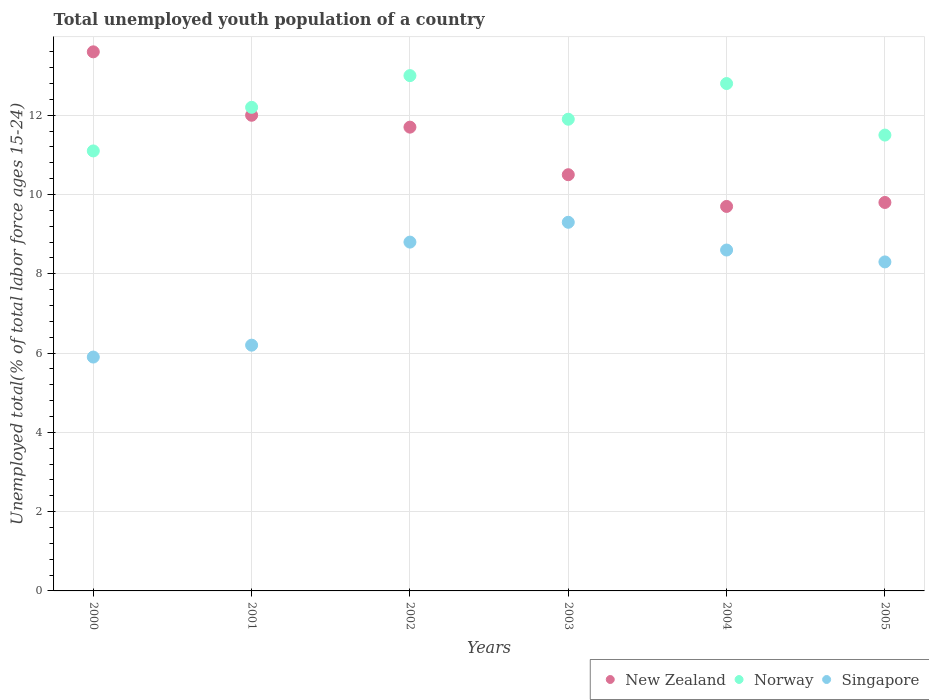What is the percentage of total unemployed youth population of a country in Norway in 2000?
Offer a very short reply. 11.1. Across all years, what is the maximum percentage of total unemployed youth population of a country in New Zealand?
Offer a very short reply. 13.6. Across all years, what is the minimum percentage of total unemployed youth population of a country in New Zealand?
Give a very brief answer. 9.7. In which year was the percentage of total unemployed youth population of a country in New Zealand minimum?
Your answer should be compact. 2004. What is the total percentage of total unemployed youth population of a country in Norway in the graph?
Provide a succinct answer. 72.5. What is the difference between the percentage of total unemployed youth population of a country in New Zealand in 2002 and that in 2003?
Ensure brevity in your answer.  1.2. What is the difference between the percentage of total unemployed youth population of a country in Norway in 2004 and the percentage of total unemployed youth population of a country in Singapore in 2000?
Give a very brief answer. 6.9. What is the average percentage of total unemployed youth population of a country in Singapore per year?
Give a very brief answer. 7.85. In the year 2001, what is the difference between the percentage of total unemployed youth population of a country in Singapore and percentage of total unemployed youth population of a country in New Zealand?
Keep it short and to the point. -5.8. In how many years, is the percentage of total unemployed youth population of a country in Singapore greater than 13.2 %?
Offer a terse response. 0. What is the ratio of the percentage of total unemployed youth population of a country in Norway in 2001 to that in 2003?
Give a very brief answer. 1.03. Is the percentage of total unemployed youth population of a country in Singapore in 2000 less than that in 2001?
Provide a short and direct response. Yes. What is the difference between the highest and the second highest percentage of total unemployed youth population of a country in Norway?
Offer a very short reply. 0.2. What is the difference between the highest and the lowest percentage of total unemployed youth population of a country in New Zealand?
Provide a succinct answer. 3.9. Is the sum of the percentage of total unemployed youth population of a country in New Zealand in 2003 and 2004 greater than the maximum percentage of total unemployed youth population of a country in Norway across all years?
Offer a very short reply. Yes. Is it the case that in every year, the sum of the percentage of total unemployed youth population of a country in Norway and percentage of total unemployed youth population of a country in Singapore  is greater than the percentage of total unemployed youth population of a country in New Zealand?
Give a very brief answer. Yes. Does the percentage of total unemployed youth population of a country in New Zealand monotonically increase over the years?
Provide a short and direct response. No. Is the percentage of total unemployed youth population of a country in New Zealand strictly greater than the percentage of total unemployed youth population of a country in Singapore over the years?
Provide a succinct answer. Yes. What is the difference between two consecutive major ticks on the Y-axis?
Keep it short and to the point. 2. Does the graph contain any zero values?
Provide a succinct answer. No. Where does the legend appear in the graph?
Keep it short and to the point. Bottom right. How many legend labels are there?
Offer a very short reply. 3. How are the legend labels stacked?
Keep it short and to the point. Horizontal. What is the title of the graph?
Your answer should be compact. Total unemployed youth population of a country. Does "Bahamas" appear as one of the legend labels in the graph?
Provide a succinct answer. No. What is the label or title of the X-axis?
Offer a very short reply. Years. What is the label or title of the Y-axis?
Provide a short and direct response. Unemployed total(% of total labor force ages 15-24). What is the Unemployed total(% of total labor force ages 15-24) in New Zealand in 2000?
Your response must be concise. 13.6. What is the Unemployed total(% of total labor force ages 15-24) of Norway in 2000?
Make the answer very short. 11.1. What is the Unemployed total(% of total labor force ages 15-24) of Singapore in 2000?
Make the answer very short. 5.9. What is the Unemployed total(% of total labor force ages 15-24) of Norway in 2001?
Provide a short and direct response. 12.2. What is the Unemployed total(% of total labor force ages 15-24) in Singapore in 2001?
Give a very brief answer. 6.2. What is the Unemployed total(% of total labor force ages 15-24) of New Zealand in 2002?
Provide a short and direct response. 11.7. What is the Unemployed total(% of total labor force ages 15-24) in Norway in 2002?
Your answer should be compact. 13. What is the Unemployed total(% of total labor force ages 15-24) in Singapore in 2002?
Ensure brevity in your answer.  8.8. What is the Unemployed total(% of total labor force ages 15-24) in New Zealand in 2003?
Provide a succinct answer. 10.5. What is the Unemployed total(% of total labor force ages 15-24) of Norway in 2003?
Offer a very short reply. 11.9. What is the Unemployed total(% of total labor force ages 15-24) of Singapore in 2003?
Keep it short and to the point. 9.3. What is the Unemployed total(% of total labor force ages 15-24) of New Zealand in 2004?
Give a very brief answer. 9.7. What is the Unemployed total(% of total labor force ages 15-24) in Norway in 2004?
Keep it short and to the point. 12.8. What is the Unemployed total(% of total labor force ages 15-24) of Singapore in 2004?
Provide a short and direct response. 8.6. What is the Unemployed total(% of total labor force ages 15-24) of New Zealand in 2005?
Provide a succinct answer. 9.8. What is the Unemployed total(% of total labor force ages 15-24) in Norway in 2005?
Provide a succinct answer. 11.5. What is the Unemployed total(% of total labor force ages 15-24) of Singapore in 2005?
Give a very brief answer. 8.3. Across all years, what is the maximum Unemployed total(% of total labor force ages 15-24) in New Zealand?
Provide a succinct answer. 13.6. Across all years, what is the maximum Unemployed total(% of total labor force ages 15-24) of Norway?
Your answer should be compact. 13. Across all years, what is the maximum Unemployed total(% of total labor force ages 15-24) in Singapore?
Offer a terse response. 9.3. Across all years, what is the minimum Unemployed total(% of total labor force ages 15-24) of New Zealand?
Your response must be concise. 9.7. Across all years, what is the minimum Unemployed total(% of total labor force ages 15-24) in Norway?
Your answer should be compact. 11.1. Across all years, what is the minimum Unemployed total(% of total labor force ages 15-24) in Singapore?
Your response must be concise. 5.9. What is the total Unemployed total(% of total labor force ages 15-24) of New Zealand in the graph?
Offer a terse response. 67.3. What is the total Unemployed total(% of total labor force ages 15-24) in Norway in the graph?
Your answer should be compact. 72.5. What is the total Unemployed total(% of total labor force ages 15-24) in Singapore in the graph?
Your response must be concise. 47.1. What is the difference between the Unemployed total(% of total labor force ages 15-24) in Singapore in 2000 and that in 2001?
Provide a short and direct response. -0.3. What is the difference between the Unemployed total(% of total labor force ages 15-24) of New Zealand in 2000 and that in 2002?
Your answer should be compact. 1.9. What is the difference between the Unemployed total(% of total labor force ages 15-24) of Norway in 2000 and that in 2002?
Your answer should be compact. -1.9. What is the difference between the Unemployed total(% of total labor force ages 15-24) of New Zealand in 2000 and that in 2003?
Your answer should be very brief. 3.1. What is the difference between the Unemployed total(% of total labor force ages 15-24) in Singapore in 2000 and that in 2005?
Make the answer very short. -2.4. What is the difference between the Unemployed total(% of total labor force ages 15-24) of Norway in 2001 and that in 2003?
Provide a short and direct response. 0.3. What is the difference between the Unemployed total(% of total labor force ages 15-24) in Singapore in 2001 and that in 2003?
Offer a terse response. -3.1. What is the difference between the Unemployed total(% of total labor force ages 15-24) of New Zealand in 2001 and that in 2004?
Keep it short and to the point. 2.3. What is the difference between the Unemployed total(% of total labor force ages 15-24) in Singapore in 2001 and that in 2004?
Offer a terse response. -2.4. What is the difference between the Unemployed total(% of total labor force ages 15-24) of New Zealand in 2001 and that in 2005?
Provide a succinct answer. 2.2. What is the difference between the Unemployed total(% of total labor force ages 15-24) of Singapore in 2001 and that in 2005?
Provide a short and direct response. -2.1. What is the difference between the Unemployed total(% of total labor force ages 15-24) of New Zealand in 2002 and that in 2003?
Your answer should be compact. 1.2. What is the difference between the Unemployed total(% of total labor force ages 15-24) in Norway in 2002 and that in 2003?
Give a very brief answer. 1.1. What is the difference between the Unemployed total(% of total labor force ages 15-24) of Singapore in 2002 and that in 2005?
Ensure brevity in your answer.  0.5. What is the difference between the Unemployed total(% of total labor force ages 15-24) in New Zealand in 2003 and that in 2004?
Your answer should be compact. 0.8. What is the difference between the Unemployed total(% of total labor force ages 15-24) in Norway in 2003 and that in 2004?
Provide a succinct answer. -0.9. What is the difference between the Unemployed total(% of total labor force ages 15-24) in Singapore in 2003 and that in 2004?
Ensure brevity in your answer.  0.7. What is the difference between the Unemployed total(% of total labor force ages 15-24) in New Zealand in 2003 and that in 2005?
Provide a succinct answer. 0.7. What is the difference between the Unemployed total(% of total labor force ages 15-24) of Norway in 2003 and that in 2005?
Ensure brevity in your answer.  0.4. What is the difference between the Unemployed total(% of total labor force ages 15-24) of New Zealand in 2004 and that in 2005?
Provide a short and direct response. -0.1. What is the difference between the Unemployed total(% of total labor force ages 15-24) in Norway in 2004 and that in 2005?
Your answer should be compact. 1.3. What is the difference between the Unemployed total(% of total labor force ages 15-24) of Singapore in 2004 and that in 2005?
Keep it short and to the point. 0.3. What is the difference between the Unemployed total(% of total labor force ages 15-24) in New Zealand in 2000 and the Unemployed total(% of total labor force ages 15-24) in Norway in 2001?
Your answer should be very brief. 1.4. What is the difference between the Unemployed total(% of total labor force ages 15-24) in New Zealand in 2000 and the Unemployed total(% of total labor force ages 15-24) in Singapore in 2001?
Give a very brief answer. 7.4. What is the difference between the Unemployed total(% of total labor force ages 15-24) of New Zealand in 2000 and the Unemployed total(% of total labor force ages 15-24) of Norway in 2002?
Your answer should be very brief. 0.6. What is the difference between the Unemployed total(% of total labor force ages 15-24) in New Zealand in 2000 and the Unemployed total(% of total labor force ages 15-24) in Singapore in 2002?
Offer a very short reply. 4.8. What is the difference between the Unemployed total(% of total labor force ages 15-24) of Norway in 2000 and the Unemployed total(% of total labor force ages 15-24) of Singapore in 2002?
Keep it short and to the point. 2.3. What is the difference between the Unemployed total(% of total labor force ages 15-24) of Norway in 2000 and the Unemployed total(% of total labor force ages 15-24) of Singapore in 2003?
Offer a terse response. 1.8. What is the difference between the Unemployed total(% of total labor force ages 15-24) of New Zealand in 2000 and the Unemployed total(% of total labor force ages 15-24) of Norway in 2004?
Offer a very short reply. 0.8. What is the difference between the Unemployed total(% of total labor force ages 15-24) in New Zealand in 2000 and the Unemployed total(% of total labor force ages 15-24) in Singapore in 2004?
Provide a short and direct response. 5. What is the difference between the Unemployed total(% of total labor force ages 15-24) of Norway in 2000 and the Unemployed total(% of total labor force ages 15-24) of Singapore in 2004?
Offer a very short reply. 2.5. What is the difference between the Unemployed total(% of total labor force ages 15-24) in New Zealand in 2000 and the Unemployed total(% of total labor force ages 15-24) in Singapore in 2005?
Give a very brief answer. 5.3. What is the difference between the Unemployed total(% of total labor force ages 15-24) in New Zealand in 2001 and the Unemployed total(% of total labor force ages 15-24) in Norway in 2002?
Your answer should be compact. -1. What is the difference between the Unemployed total(% of total labor force ages 15-24) of Norway in 2001 and the Unemployed total(% of total labor force ages 15-24) of Singapore in 2002?
Keep it short and to the point. 3.4. What is the difference between the Unemployed total(% of total labor force ages 15-24) in Norway in 2001 and the Unemployed total(% of total labor force ages 15-24) in Singapore in 2003?
Your response must be concise. 2.9. What is the difference between the Unemployed total(% of total labor force ages 15-24) in New Zealand in 2001 and the Unemployed total(% of total labor force ages 15-24) in Norway in 2004?
Give a very brief answer. -0.8. What is the difference between the Unemployed total(% of total labor force ages 15-24) in New Zealand in 2001 and the Unemployed total(% of total labor force ages 15-24) in Singapore in 2004?
Offer a very short reply. 3.4. What is the difference between the Unemployed total(% of total labor force ages 15-24) in New Zealand in 2002 and the Unemployed total(% of total labor force ages 15-24) in Singapore in 2003?
Your response must be concise. 2.4. What is the difference between the Unemployed total(% of total labor force ages 15-24) of New Zealand in 2002 and the Unemployed total(% of total labor force ages 15-24) of Norway in 2004?
Offer a terse response. -1.1. What is the difference between the Unemployed total(% of total labor force ages 15-24) of New Zealand in 2002 and the Unemployed total(% of total labor force ages 15-24) of Singapore in 2004?
Your answer should be very brief. 3.1. What is the difference between the Unemployed total(% of total labor force ages 15-24) of New Zealand in 2002 and the Unemployed total(% of total labor force ages 15-24) of Norway in 2005?
Make the answer very short. 0.2. What is the difference between the Unemployed total(% of total labor force ages 15-24) in New Zealand in 2003 and the Unemployed total(% of total labor force ages 15-24) in Singapore in 2004?
Your answer should be compact. 1.9. What is the difference between the Unemployed total(% of total labor force ages 15-24) in New Zealand in 2003 and the Unemployed total(% of total labor force ages 15-24) in Singapore in 2005?
Make the answer very short. 2.2. What is the difference between the Unemployed total(% of total labor force ages 15-24) in Norway in 2003 and the Unemployed total(% of total labor force ages 15-24) in Singapore in 2005?
Make the answer very short. 3.6. What is the difference between the Unemployed total(% of total labor force ages 15-24) of New Zealand in 2004 and the Unemployed total(% of total labor force ages 15-24) of Norway in 2005?
Make the answer very short. -1.8. What is the difference between the Unemployed total(% of total labor force ages 15-24) in Norway in 2004 and the Unemployed total(% of total labor force ages 15-24) in Singapore in 2005?
Make the answer very short. 4.5. What is the average Unemployed total(% of total labor force ages 15-24) of New Zealand per year?
Your answer should be very brief. 11.22. What is the average Unemployed total(% of total labor force ages 15-24) in Norway per year?
Your answer should be very brief. 12.08. What is the average Unemployed total(% of total labor force ages 15-24) of Singapore per year?
Make the answer very short. 7.85. In the year 2000, what is the difference between the Unemployed total(% of total labor force ages 15-24) in New Zealand and Unemployed total(% of total labor force ages 15-24) in Singapore?
Make the answer very short. 7.7. In the year 2001, what is the difference between the Unemployed total(% of total labor force ages 15-24) in New Zealand and Unemployed total(% of total labor force ages 15-24) in Singapore?
Your answer should be compact. 5.8. In the year 2001, what is the difference between the Unemployed total(% of total labor force ages 15-24) of Norway and Unemployed total(% of total labor force ages 15-24) of Singapore?
Provide a succinct answer. 6. In the year 2002, what is the difference between the Unemployed total(% of total labor force ages 15-24) in New Zealand and Unemployed total(% of total labor force ages 15-24) in Norway?
Ensure brevity in your answer.  -1.3. In the year 2003, what is the difference between the Unemployed total(% of total labor force ages 15-24) in New Zealand and Unemployed total(% of total labor force ages 15-24) in Norway?
Offer a very short reply. -1.4. In the year 2003, what is the difference between the Unemployed total(% of total labor force ages 15-24) in New Zealand and Unemployed total(% of total labor force ages 15-24) in Singapore?
Make the answer very short. 1.2. In the year 2004, what is the difference between the Unemployed total(% of total labor force ages 15-24) of New Zealand and Unemployed total(% of total labor force ages 15-24) of Singapore?
Ensure brevity in your answer.  1.1. In the year 2004, what is the difference between the Unemployed total(% of total labor force ages 15-24) of Norway and Unemployed total(% of total labor force ages 15-24) of Singapore?
Offer a terse response. 4.2. In the year 2005, what is the difference between the Unemployed total(% of total labor force ages 15-24) of New Zealand and Unemployed total(% of total labor force ages 15-24) of Singapore?
Give a very brief answer. 1.5. In the year 2005, what is the difference between the Unemployed total(% of total labor force ages 15-24) in Norway and Unemployed total(% of total labor force ages 15-24) in Singapore?
Your response must be concise. 3.2. What is the ratio of the Unemployed total(% of total labor force ages 15-24) of New Zealand in 2000 to that in 2001?
Give a very brief answer. 1.13. What is the ratio of the Unemployed total(% of total labor force ages 15-24) in Norway in 2000 to that in 2001?
Offer a very short reply. 0.91. What is the ratio of the Unemployed total(% of total labor force ages 15-24) of Singapore in 2000 to that in 2001?
Offer a very short reply. 0.95. What is the ratio of the Unemployed total(% of total labor force ages 15-24) in New Zealand in 2000 to that in 2002?
Offer a very short reply. 1.16. What is the ratio of the Unemployed total(% of total labor force ages 15-24) of Norway in 2000 to that in 2002?
Your answer should be very brief. 0.85. What is the ratio of the Unemployed total(% of total labor force ages 15-24) in Singapore in 2000 to that in 2002?
Offer a terse response. 0.67. What is the ratio of the Unemployed total(% of total labor force ages 15-24) of New Zealand in 2000 to that in 2003?
Provide a succinct answer. 1.3. What is the ratio of the Unemployed total(% of total labor force ages 15-24) in Norway in 2000 to that in 2003?
Provide a succinct answer. 0.93. What is the ratio of the Unemployed total(% of total labor force ages 15-24) in Singapore in 2000 to that in 2003?
Offer a very short reply. 0.63. What is the ratio of the Unemployed total(% of total labor force ages 15-24) in New Zealand in 2000 to that in 2004?
Your response must be concise. 1.4. What is the ratio of the Unemployed total(% of total labor force ages 15-24) of Norway in 2000 to that in 2004?
Offer a very short reply. 0.87. What is the ratio of the Unemployed total(% of total labor force ages 15-24) of Singapore in 2000 to that in 2004?
Your answer should be very brief. 0.69. What is the ratio of the Unemployed total(% of total labor force ages 15-24) of New Zealand in 2000 to that in 2005?
Ensure brevity in your answer.  1.39. What is the ratio of the Unemployed total(% of total labor force ages 15-24) in Norway in 2000 to that in 2005?
Provide a short and direct response. 0.97. What is the ratio of the Unemployed total(% of total labor force ages 15-24) in Singapore in 2000 to that in 2005?
Keep it short and to the point. 0.71. What is the ratio of the Unemployed total(% of total labor force ages 15-24) of New Zealand in 2001 to that in 2002?
Provide a succinct answer. 1.03. What is the ratio of the Unemployed total(% of total labor force ages 15-24) in Norway in 2001 to that in 2002?
Provide a short and direct response. 0.94. What is the ratio of the Unemployed total(% of total labor force ages 15-24) in Singapore in 2001 to that in 2002?
Your answer should be compact. 0.7. What is the ratio of the Unemployed total(% of total labor force ages 15-24) of New Zealand in 2001 to that in 2003?
Provide a short and direct response. 1.14. What is the ratio of the Unemployed total(% of total labor force ages 15-24) in Norway in 2001 to that in 2003?
Offer a very short reply. 1.03. What is the ratio of the Unemployed total(% of total labor force ages 15-24) of Singapore in 2001 to that in 2003?
Give a very brief answer. 0.67. What is the ratio of the Unemployed total(% of total labor force ages 15-24) of New Zealand in 2001 to that in 2004?
Offer a terse response. 1.24. What is the ratio of the Unemployed total(% of total labor force ages 15-24) of Norway in 2001 to that in 2004?
Keep it short and to the point. 0.95. What is the ratio of the Unemployed total(% of total labor force ages 15-24) in Singapore in 2001 to that in 2004?
Give a very brief answer. 0.72. What is the ratio of the Unemployed total(% of total labor force ages 15-24) of New Zealand in 2001 to that in 2005?
Provide a succinct answer. 1.22. What is the ratio of the Unemployed total(% of total labor force ages 15-24) of Norway in 2001 to that in 2005?
Make the answer very short. 1.06. What is the ratio of the Unemployed total(% of total labor force ages 15-24) of Singapore in 2001 to that in 2005?
Make the answer very short. 0.75. What is the ratio of the Unemployed total(% of total labor force ages 15-24) of New Zealand in 2002 to that in 2003?
Offer a terse response. 1.11. What is the ratio of the Unemployed total(% of total labor force ages 15-24) of Norway in 2002 to that in 2003?
Give a very brief answer. 1.09. What is the ratio of the Unemployed total(% of total labor force ages 15-24) of Singapore in 2002 to that in 2003?
Your response must be concise. 0.95. What is the ratio of the Unemployed total(% of total labor force ages 15-24) of New Zealand in 2002 to that in 2004?
Give a very brief answer. 1.21. What is the ratio of the Unemployed total(% of total labor force ages 15-24) of Norway in 2002 to that in 2004?
Your response must be concise. 1.02. What is the ratio of the Unemployed total(% of total labor force ages 15-24) of Singapore in 2002 to that in 2004?
Your response must be concise. 1.02. What is the ratio of the Unemployed total(% of total labor force ages 15-24) of New Zealand in 2002 to that in 2005?
Your answer should be compact. 1.19. What is the ratio of the Unemployed total(% of total labor force ages 15-24) in Norway in 2002 to that in 2005?
Your answer should be compact. 1.13. What is the ratio of the Unemployed total(% of total labor force ages 15-24) of Singapore in 2002 to that in 2005?
Keep it short and to the point. 1.06. What is the ratio of the Unemployed total(% of total labor force ages 15-24) of New Zealand in 2003 to that in 2004?
Offer a terse response. 1.08. What is the ratio of the Unemployed total(% of total labor force ages 15-24) of Norway in 2003 to that in 2004?
Your answer should be compact. 0.93. What is the ratio of the Unemployed total(% of total labor force ages 15-24) of Singapore in 2003 to that in 2004?
Provide a short and direct response. 1.08. What is the ratio of the Unemployed total(% of total labor force ages 15-24) in New Zealand in 2003 to that in 2005?
Your answer should be compact. 1.07. What is the ratio of the Unemployed total(% of total labor force ages 15-24) in Norway in 2003 to that in 2005?
Offer a very short reply. 1.03. What is the ratio of the Unemployed total(% of total labor force ages 15-24) of Singapore in 2003 to that in 2005?
Your answer should be very brief. 1.12. What is the ratio of the Unemployed total(% of total labor force ages 15-24) of New Zealand in 2004 to that in 2005?
Your answer should be compact. 0.99. What is the ratio of the Unemployed total(% of total labor force ages 15-24) of Norway in 2004 to that in 2005?
Ensure brevity in your answer.  1.11. What is the ratio of the Unemployed total(% of total labor force ages 15-24) in Singapore in 2004 to that in 2005?
Provide a succinct answer. 1.04. What is the difference between the highest and the second highest Unemployed total(% of total labor force ages 15-24) in Norway?
Give a very brief answer. 0.2. What is the difference between the highest and the second highest Unemployed total(% of total labor force ages 15-24) in Singapore?
Offer a very short reply. 0.5. What is the difference between the highest and the lowest Unemployed total(% of total labor force ages 15-24) of New Zealand?
Keep it short and to the point. 3.9. What is the difference between the highest and the lowest Unemployed total(% of total labor force ages 15-24) of Norway?
Provide a short and direct response. 1.9. What is the difference between the highest and the lowest Unemployed total(% of total labor force ages 15-24) in Singapore?
Provide a short and direct response. 3.4. 